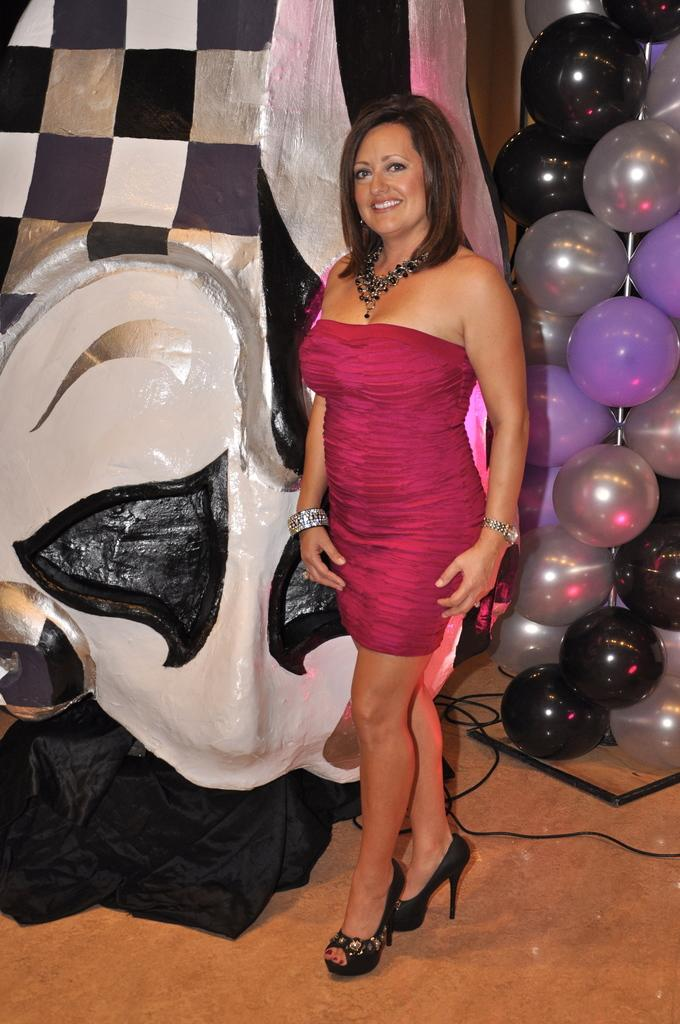What is the primary subject in the image? There is a woman in the image. What is the woman doing in the image? The woman is standing on the floor and smiling. What can be seen in the background of the image? There is an object, black color cloth, balloons, cables, and a stand on the floor in the background of the image. What type of record is being played in the background of the image? There is no record present in the image; it features a woman standing on the floor and smiling, with various objects in the background. What type of flesh can be seen in the image? There is no flesh visible in the image; it features a woman standing on the floor and smiling, with various objects in the background. 